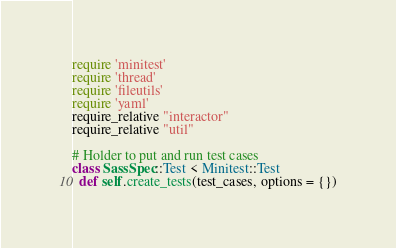Convert code to text. <code><loc_0><loc_0><loc_500><loc_500><_Ruby_>require 'minitest'
require 'thread'
require 'fileutils'
require 'yaml'
require_relative "interactor"
require_relative "util"

# Holder to put and run test cases
class SassSpec::Test < Minitest::Test
  def self.create_tests(test_cases, options = {})</code> 